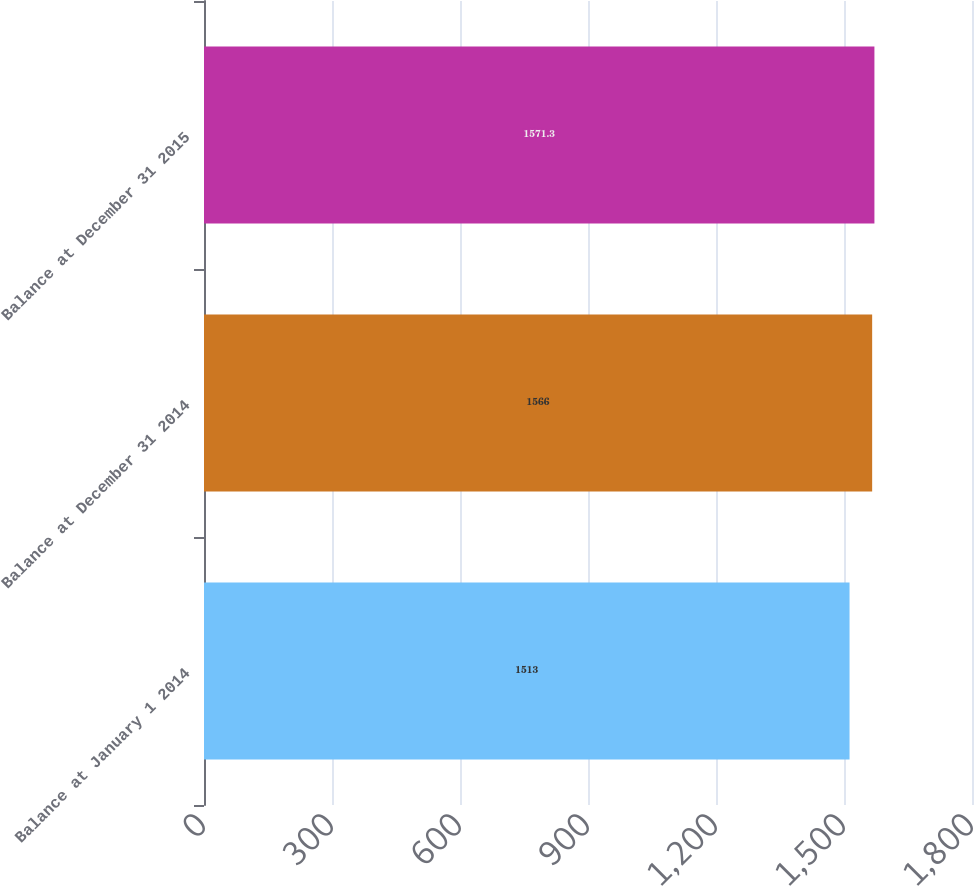<chart> <loc_0><loc_0><loc_500><loc_500><bar_chart><fcel>Balance at January 1 2014<fcel>Balance at December 31 2014<fcel>Balance at December 31 2015<nl><fcel>1513<fcel>1566<fcel>1571.3<nl></chart> 